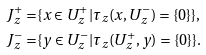Convert formula to latex. <formula><loc_0><loc_0><loc_500><loc_500>J ^ { + } _ { z } = & \{ x \in U ^ { + } _ { z } | \tau _ { z } ( x , U ^ { - } _ { z } ) = \{ 0 \} \} , \\ J ^ { - } _ { z } = & \{ y \in U ^ { - } _ { z } | \tau _ { z } ( U ^ { + } _ { z } , y ) = \{ 0 \} \} .</formula> 